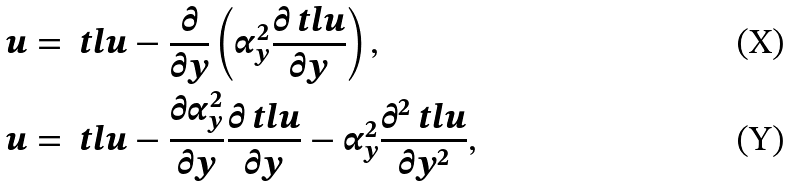Convert formula to latex. <formula><loc_0><loc_0><loc_500><loc_500>u & = \ t l { u } - \frac { \partial } { \partial y } \left ( \alpha ^ { 2 } _ { y } \frac { \partial \ t l { u } } { \partial y } \right ) , \\ u & = \ t l { u } - \frac { \partial \alpha ^ { 2 } _ { y } } { \partial y } \frac { \partial \ t l { u } } { \partial y } - \alpha ^ { 2 } _ { y } \frac { \partial ^ { 2 } \ t l { u } } { \partial y ^ { 2 } } ,</formula> 